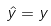<formula> <loc_0><loc_0><loc_500><loc_500>\hat { y } = y</formula> 